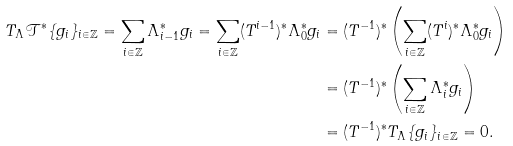Convert formula to latex. <formula><loc_0><loc_0><loc_500><loc_500>T _ { \Lambda } \mathcal { T } ^ { * } \{ g _ { i } \} _ { i \in \mathbb { Z } } = \sum _ { i \in \mathbb { Z } } \Lambda _ { i - 1 } ^ { * } g _ { i } = \sum _ { i \in \mathbb { Z } } ( T ^ { i - 1 } ) ^ { * } \Lambda _ { 0 } ^ { * } g _ { i } & = ( T ^ { - 1 } ) ^ { * } \left ( \sum _ { i \in \mathbb { Z } } ( T ^ { i } ) ^ { * } \Lambda _ { 0 } ^ { * } g _ { i } \right ) \\ & = ( T ^ { - 1 } ) ^ { * } \left ( \sum _ { i \in \mathbb { Z } } \Lambda _ { i } ^ { * } g _ { i } \right ) \\ & = ( T ^ { - 1 } ) ^ { * } T _ { \Lambda } \{ g _ { i } \} _ { i \in \mathbb { Z } } = 0 .</formula> 